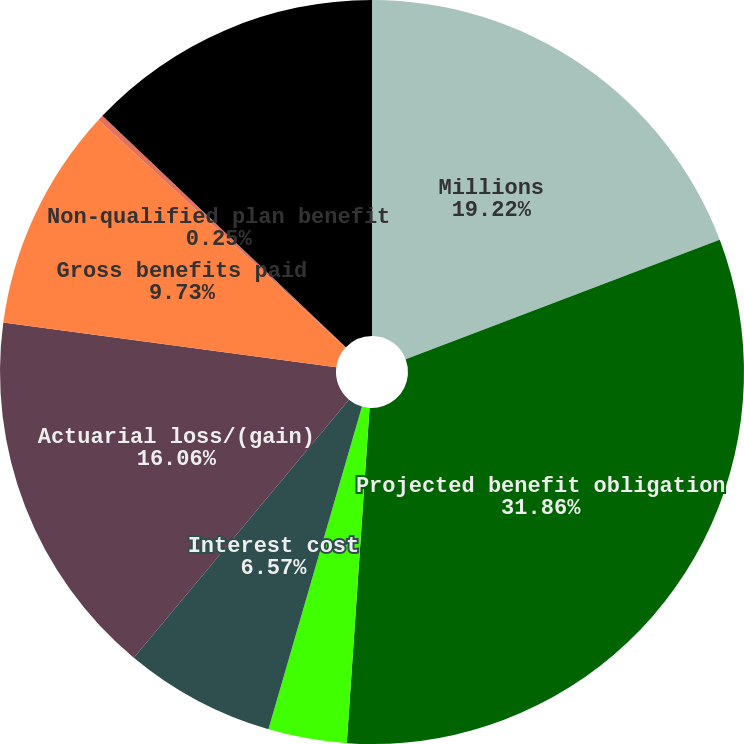<chart> <loc_0><loc_0><loc_500><loc_500><pie_chart><fcel>Millions<fcel>Projected benefit obligation<fcel>Service cost<fcel>Interest cost<fcel>Actuarial loss/(gain)<fcel>Gross benefits paid<fcel>Non-qualified plan benefit<fcel>Funded status at end of year<nl><fcel>19.22%<fcel>31.86%<fcel>3.41%<fcel>6.57%<fcel>16.06%<fcel>9.73%<fcel>0.25%<fcel>12.9%<nl></chart> 